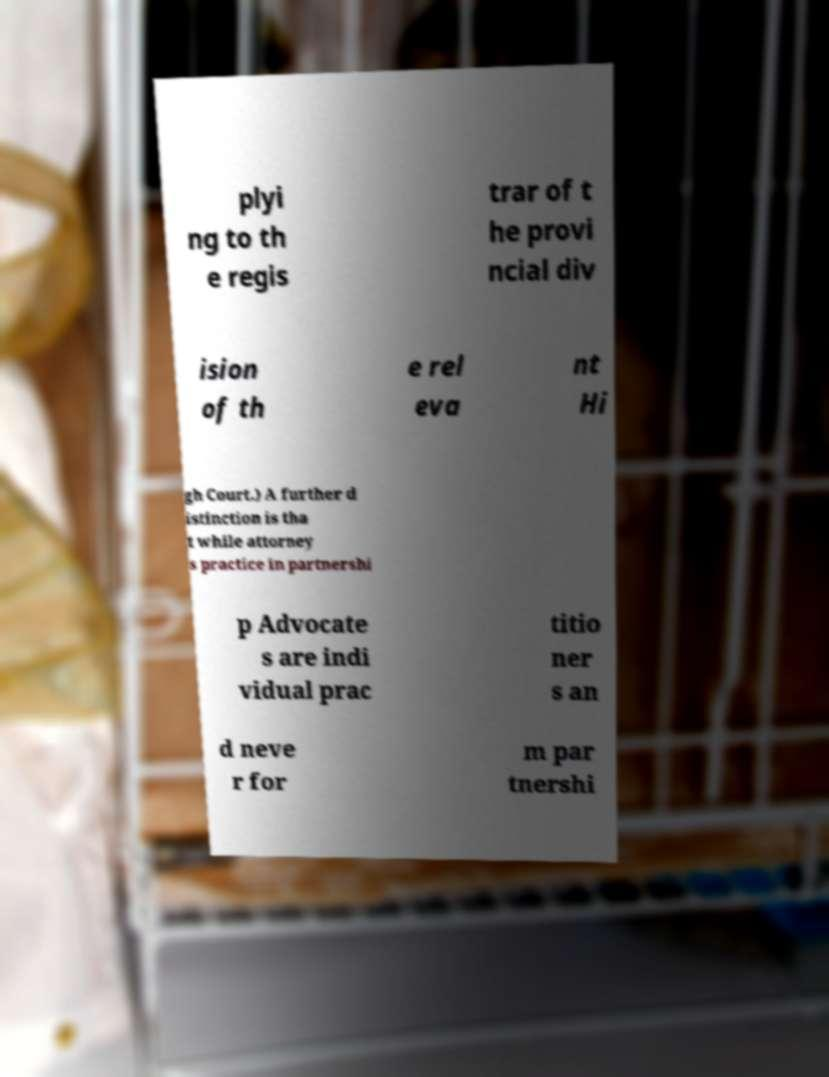Please identify and transcribe the text found in this image. plyi ng to th e regis trar of t he provi ncial div ision of th e rel eva nt Hi gh Court.) A further d istinction is tha t while attorney s practice in partnershi p Advocate s are indi vidual prac titio ner s an d neve r for m par tnershi 